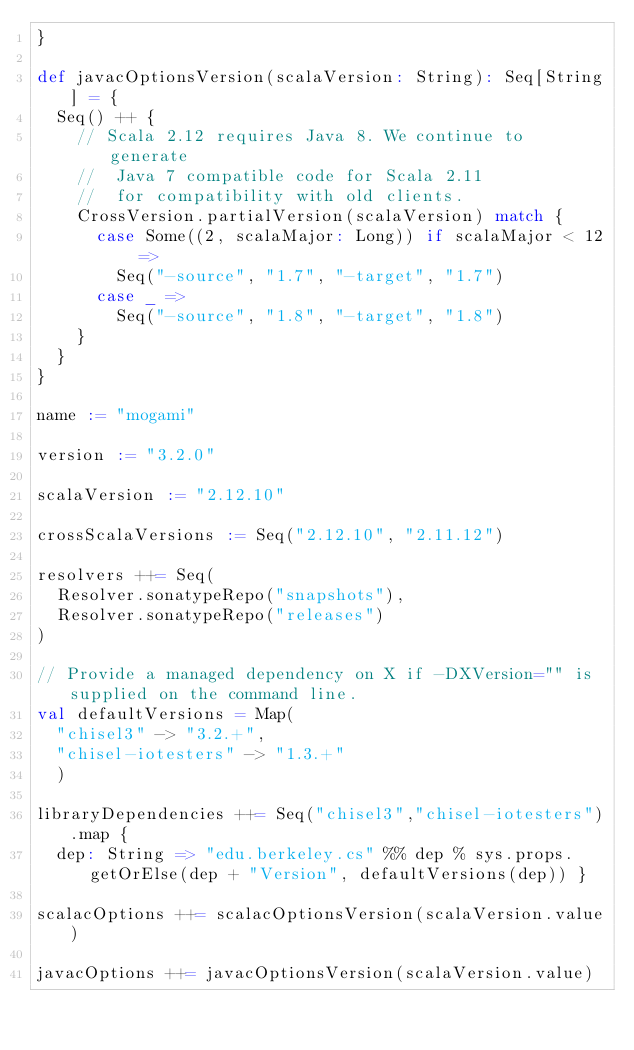<code> <loc_0><loc_0><loc_500><loc_500><_Scala_>}

def javacOptionsVersion(scalaVersion: String): Seq[String] = {
  Seq() ++ {
    // Scala 2.12 requires Java 8. We continue to generate
    //  Java 7 compatible code for Scala 2.11
    //  for compatibility with old clients.
    CrossVersion.partialVersion(scalaVersion) match {
      case Some((2, scalaMajor: Long)) if scalaMajor < 12 =>
        Seq("-source", "1.7", "-target", "1.7")
      case _ =>
        Seq("-source", "1.8", "-target", "1.8")
    }
  }
}

name := "mogami"

version := "3.2.0"

scalaVersion := "2.12.10"

crossScalaVersions := Seq("2.12.10", "2.11.12")

resolvers ++= Seq(
  Resolver.sonatypeRepo("snapshots"),
  Resolver.sonatypeRepo("releases")
)

// Provide a managed dependency on X if -DXVersion="" is supplied on the command line.
val defaultVersions = Map(
  "chisel3" -> "3.2.+",
  "chisel-iotesters" -> "1.3.+"
  )

libraryDependencies ++= Seq("chisel3","chisel-iotesters").map {
  dep: String => "edu.berkeley.cs" %% dep % sys.props.getOrElse(dep + "Version", defaultVersions(dep)) }

scalacOptions ++= scalacOptionsVersion(scalaVersion.value)

javacOptions ++= javacOptionsVersion(scalaVersion.value)
</code> 